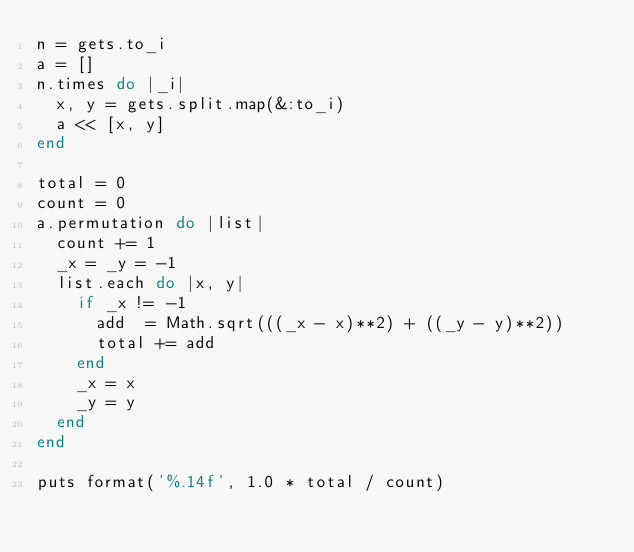<code> <loc_0><loc_0><loc_500><loc_500><_Ruby_>n = gets.to_i
a = []
n.times do |_i|
  x, y = gets.split.map(&:to_i)
  a << [x, y]
end

total = 0
count = 0
a.permutation do |list|
  count += 1
  _x = _y = -1
  list.each do |x, y|
    if _x != -1
      add  = Math.sqrt(((_x - x)**2) + ((_y - y)**2))
      total += add
    end
    _x = x
    _y = y
  end
end

puts format('%.14f', 1.0 * total / count)
</code> 